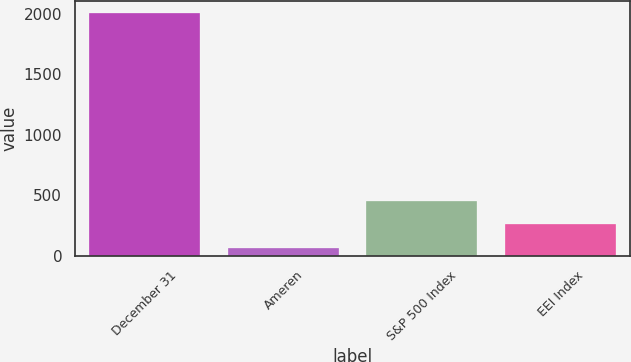<chart> <loc_0><loc_0><loc_500><loc_500><bar_chart><fcel>December 31<fcel>Ameren<fcel>S&P 500 Index<fcel>EEI Index<nl><fcel>2010<fcel>62.41<fcel>451.93<fcel>257.17<nl></chart> 